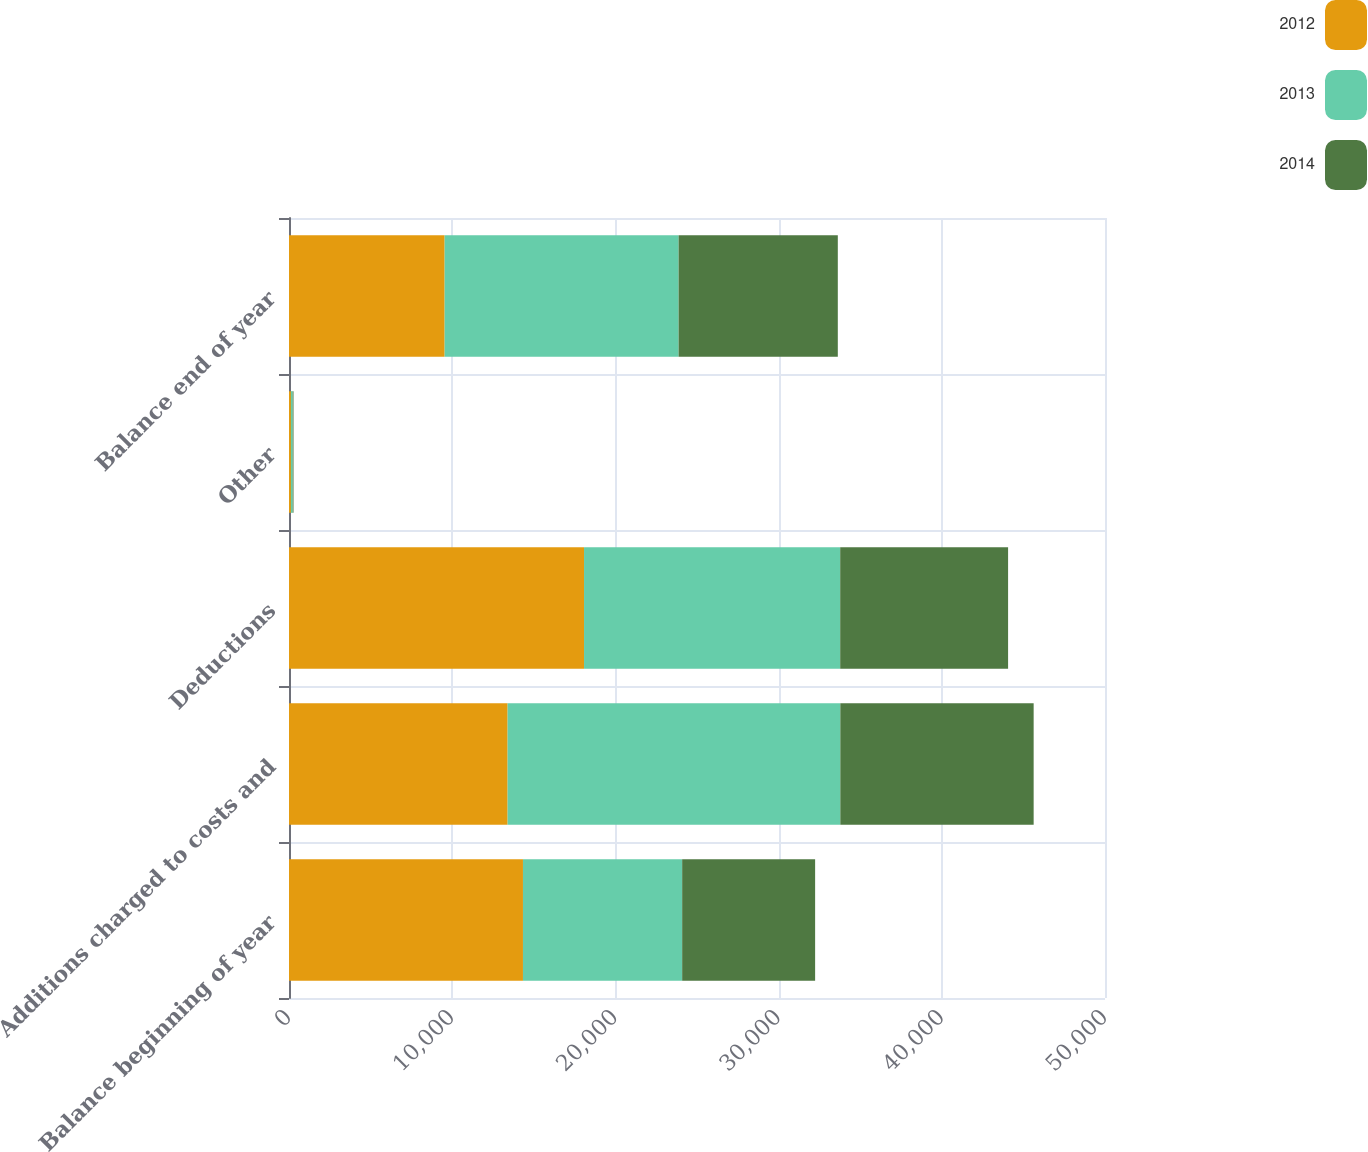<chart> <loc_0><loc_0><loc_500><loc_500><stacked_bar_chart><ecel><fcel>Balance beginning of year<fcel>Additions charged to costs and<fcel>Deductions<fcel>Other<fcel>Balance end of year<nl><fcel>2012<fcel>14336<fcel>13396<fcel>18078<fcel>117<fcel>9537<nl><fcel>2013<fcel>9755<fcel>20387<fcel>15697<fcel>109<fcel>14336<nl><fcel>2014<fcel>8147<fcel>11845<fcel>10287<fcel>50<fcel>9755<nl></chart> 